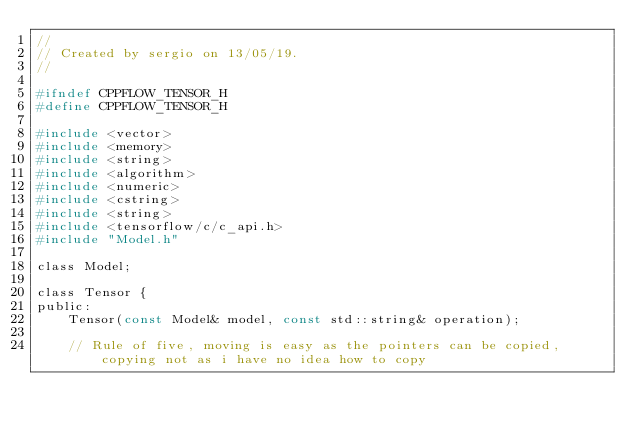<code> <loc_0><loc_0><loc_500><loc_500><_C_>//
// Created by sergio on 13/05/19.
//

#ifndef CPPFLOW_TENSOR_H
#define CPPFLOW_TENSOR_H

#include <vector>
#include <memory>
#include <string>
#include <algorithm>
#include <numeric>
#include <cstring>
#include <string> 
#include <tensorflow/c/c_api.h>
#include "Model.h"

class Model;

class Tensor {
public:
    Tensor(const Model& model, const std::string& operation);

    // Rule of five, moving is easy as the pointers can be copied, copying not as i have no idea how to copy</code> 